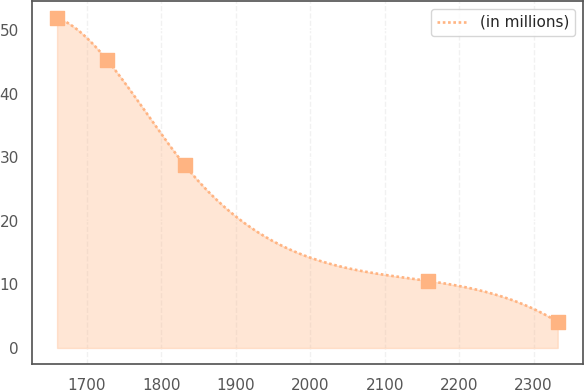<chart> <loc_0><loc_0><loc_500><loc_500><line_chart><ecel><fcel>(in millions)<nl><fcel>1659.97<fcel>51.99<nl><fcel>1727.21<fcel>45.32<nl><fcel>1831.72<fcel>28.74<nl><fcel>2158.38<fcel>10.55<nl><fcel>2332.34<fcel>4.11<nl></chart> 